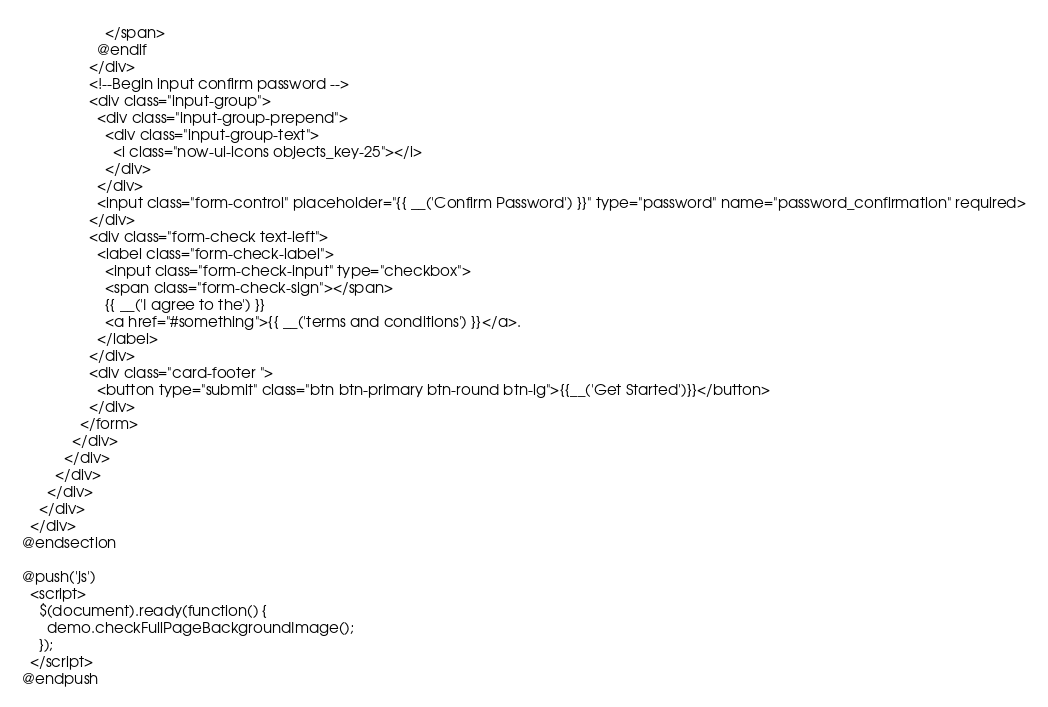<code> <loc_0><loc_0><loc_500><loc_500><_PHP_>                    </span>
                  @endif
                </div>
                <!--Begin input confirm password -->
                <div class="input-group">
                  <div class="input-group-prepend">
                    <div class="input-group-text">
                      <i class="now-ui-icons objects_key-25"></i>
                    </div>
                  </div>
                  <input class="form-control" placeholder="{{ __('Confirm Password') }}" type="password" name="password_confirmation" required>
                </div>
                <div class="form-check text-left">
                  <label class="form-check-label">
                    <input class="form-check-input" type="checkbox">
                    <span class="form-check-sign"></span>
                    {{ __('I agree to the') }}
                    <a href="#something">{{ __('terms and conditions') }}</a>.
                  </label>
                </div>
                <div class="card-footer ">
                  <button type="submit" class="btn btn-primary btn-round btn-lg">{{__('Get Started')}}</button>
                </div>
              </form>
            </div>
          </div>
        </div>
      </div>
    </div>
  </div>
@endsection

@push('js')
  <script>
    $(document).ready(function() {
      demo.checkFullPageBackgroundImage();
    });
  </script>
@endpush
</code> 